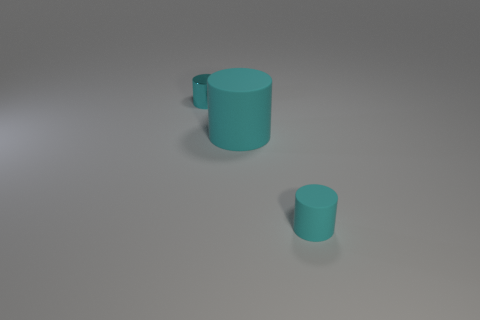There is a shiny thing; is its size the same as the rubber object behind the small rubber object?
Offer a terse response. No. Is the shape of the large thing the same as the tiny matte thing that is in front of the cyan shiny thing?
Your answer should be compact. Yes. What number of rubber objects are to the right of the large cylinder and left of the small cyan rubber cylinder?
Your response must be concise. 0. What number of gray objects are either small rubber things or big cylinders?
Provide a succinct answer. 0. Does the small thing that is right of the big cyan rubber cylinder have the same color as the cylinder left of the big cyan matte object?
Ensure brevity in your answer.  Yes. What is the color of the tiny object in front of the rubber cylinder behind the small cyan object that is in front of the cyan metallic thing?
Make the answer very short. Cyan. There is a cylinder behind the large thing; is there a cyan cylinder that is in front of it?
Your answer should be very brief. Yes. Do the tiny cyan thing that is on the left side of the large cyan cylinder and the big matte thing have the same shape?
Give a very brief answer. Yes. Is there any other thing that has the same shape as the metal object?
Provide a succinct answer. Yes. What number of cylinders are large rubber objects or cyan objects?
Your response must be concise. 3. 